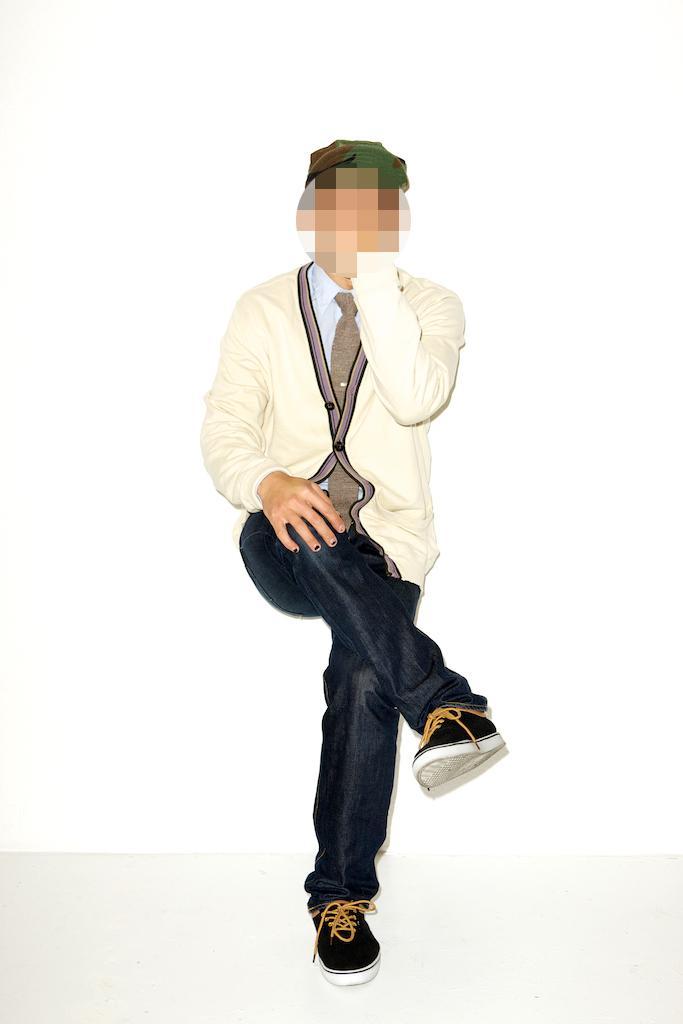In one or two sentences, can you explain what this image depicts? In this person there is a person who is hiding his face. 